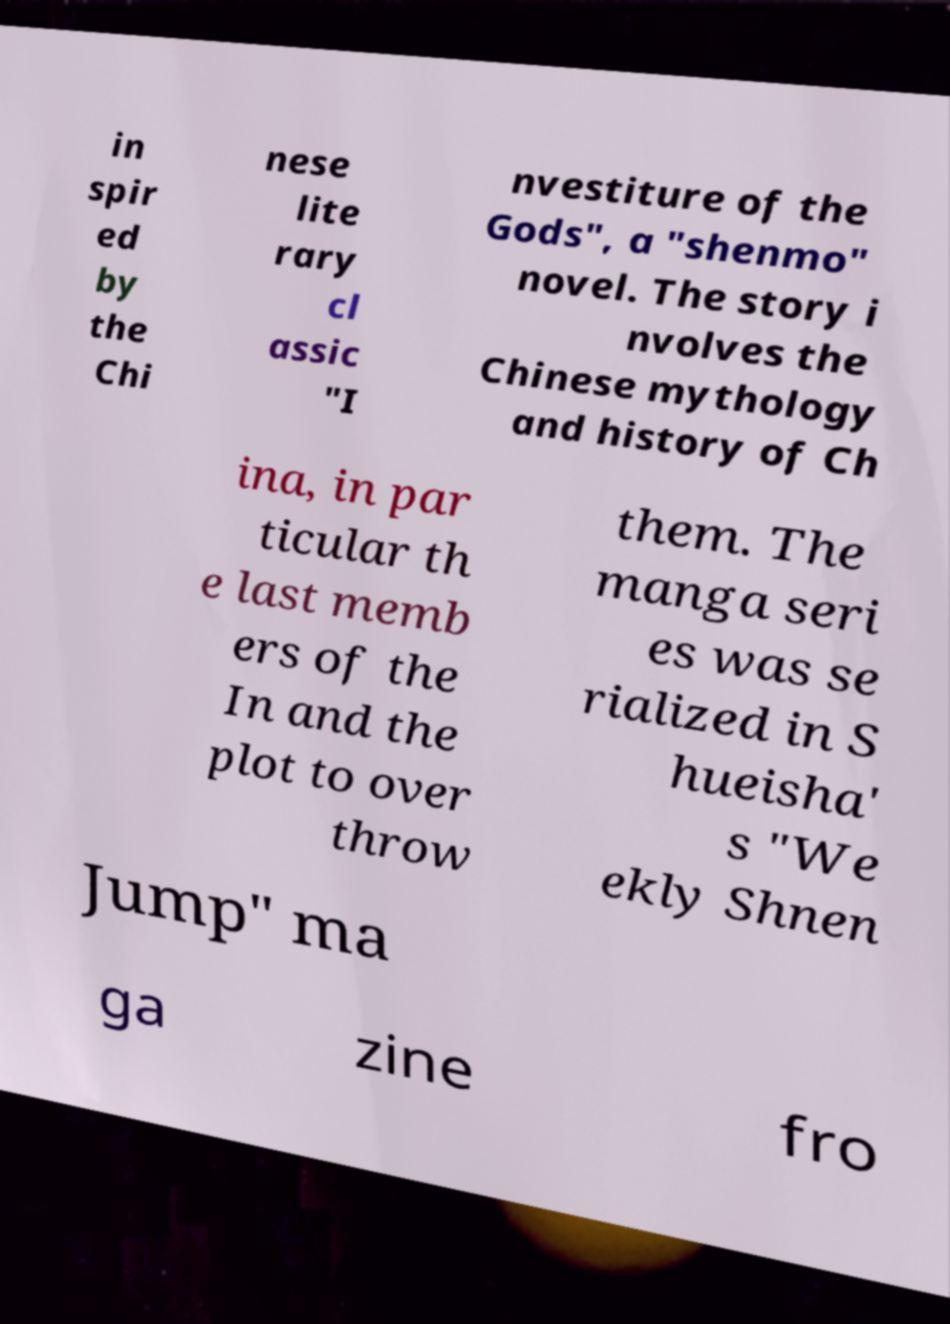Please read and relay the text visible in this image. What does it say? in spir ed by the Chi nese lite rary cl assic "I nvestiture of the Gods", a "shenmo" novel. The story i nvolves the Chinese mythology and history of Ch ina, in par ticular th e last memb ers of the In and the plot to over throw them. The manga seri es was se rialized in S hueisha' s "We ekly Shnen Jump" ma ga zine fro 